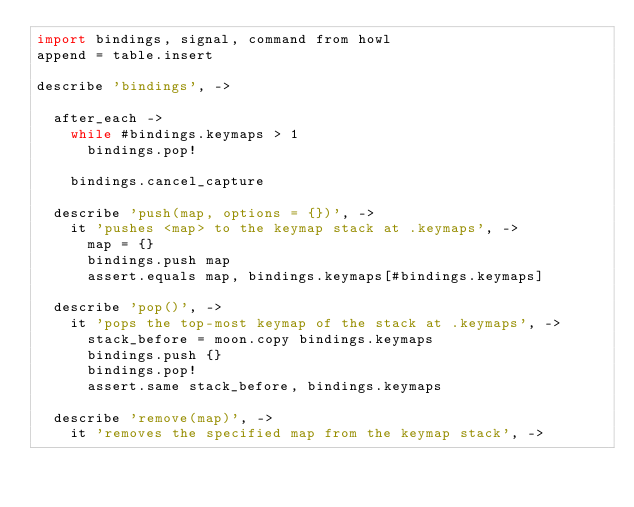Convert code to text. <code><loc_0><loc_0><loc_500><loc_500><_MoonScript_>import bindings, signal, command from howl
append = table.insert

describe 'bindings', ->

  after_each ->
    while #bindings.keymaps > 1
      bindings.pop!

    bindings.cancel_capture

  describe 'push(map, options = {})', ->
    it 'pushes <map> to the keymap stack at .keymaps', ->
      map = {}
      bindings.push map
      assert.equals map, bindings.keymaps[#bindings.keymaps]

  describe 'pop()', ->
    it 'pops the top-most keymap of the stack at .keymaps', ->
      stack_before = moon.copy bindings.keymaps
      bindings.push {}
      bindings.pop!
      assert.same stack_before, bindings.keymaps

  describe 'remove(map)', ->
    it 'removes the specified map from the keymap stack', -></code> 